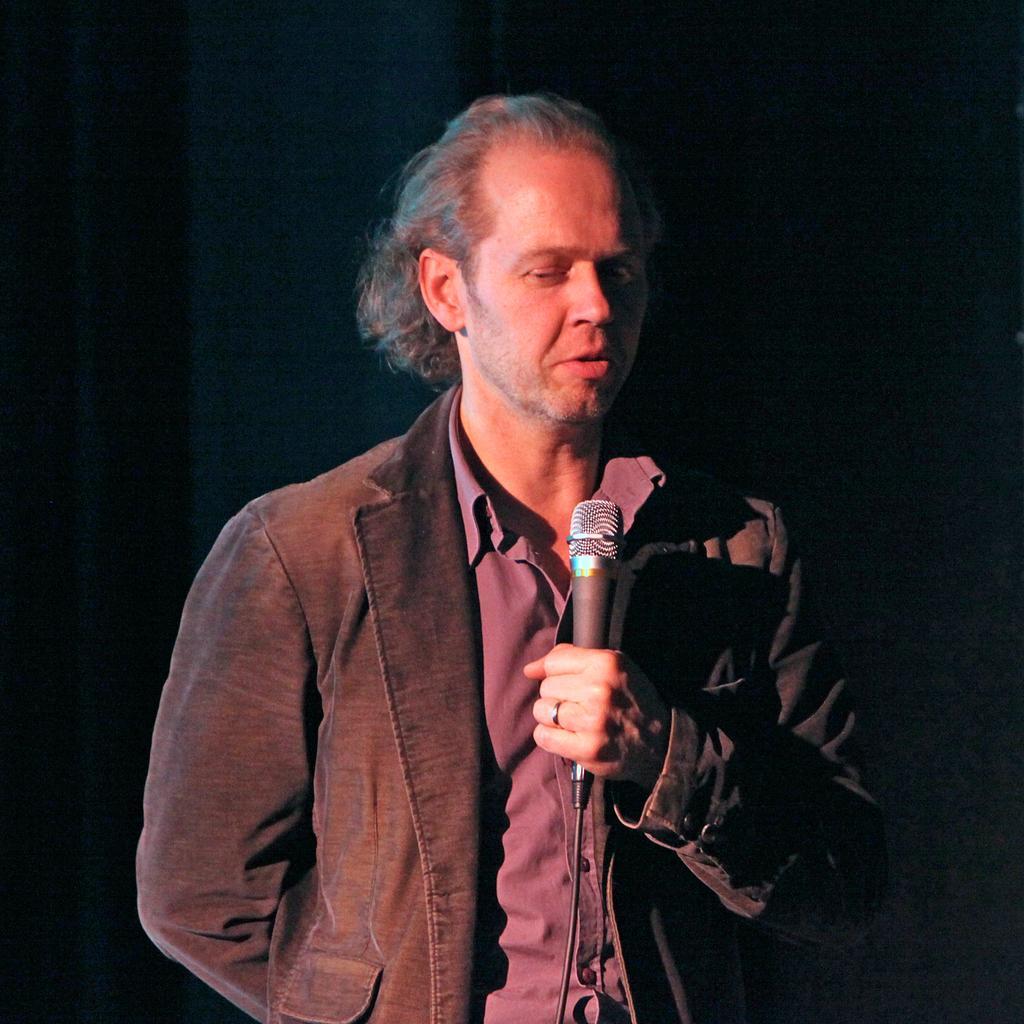Could you give a brief overview of what you see in this image? In the middle of the image a man is standing and holding a microphone and speaking. 